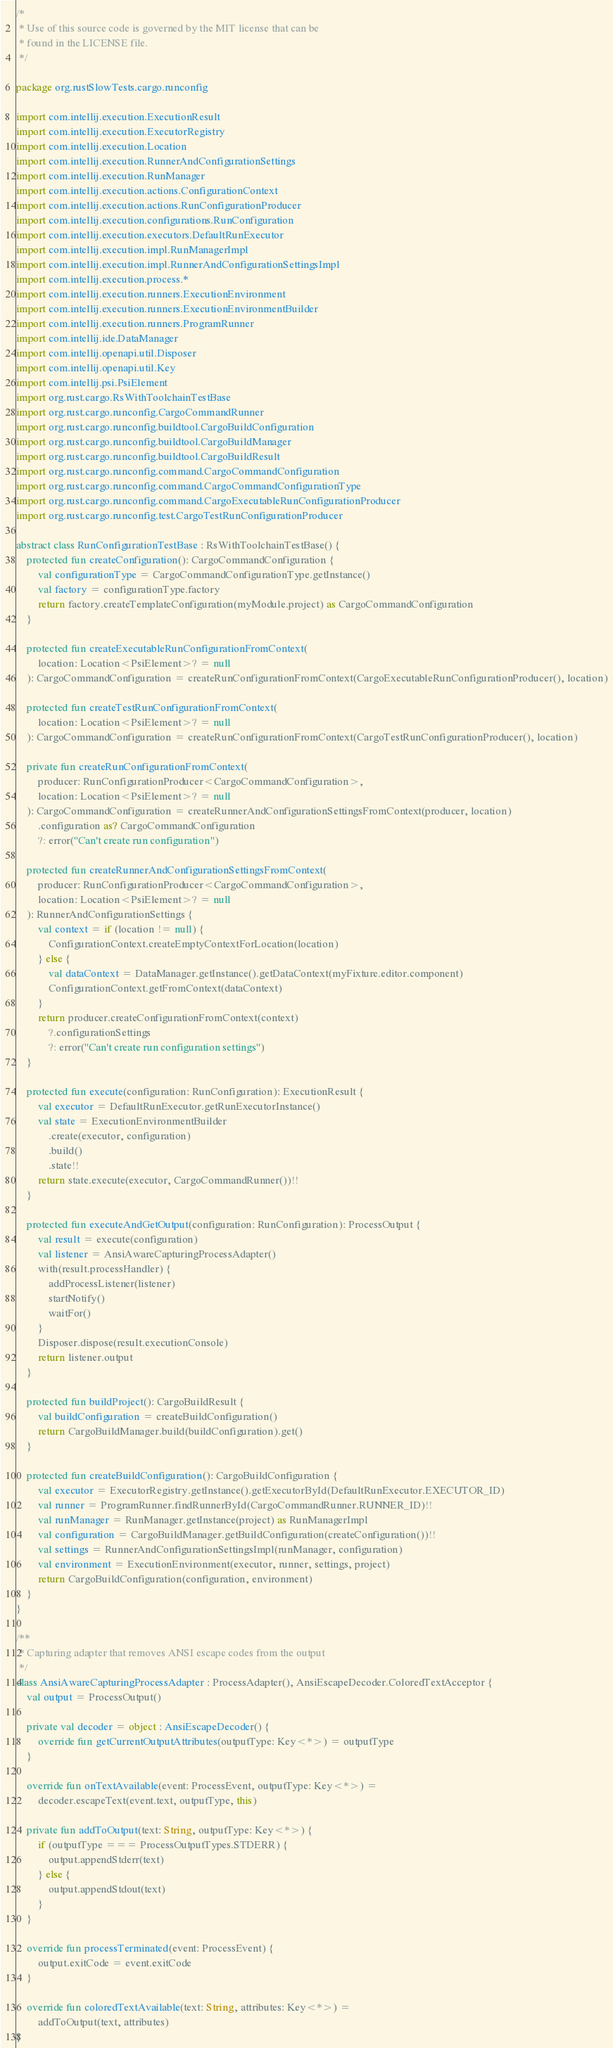Convert code to text. <code><loc_0><loc_0><loc_500><loc_500><_Kotlin_>/*
 * Use of this source code is governed by the MIT license that can be
 * found in the LICENSE file.
 */

package org.rustSlowTests.cargo.runconfig

import com.intellij.execution.ExecutionResult
import com.intellij.execution.ExecutorRegistry
import com.intellij.execution.Location
import com.intellij.execution.RunnerAndConfigurationSettings
import com.intellij.execution.RunManager
import com.intellij.execution.actions.ConfigurationContext
import com.intellij.execution.actions.RunConfigurationProducer
import com.intellij.execution.configurations.RunConfiguration
import com.intellij.execution.executors.DefaultRunExecutor
import com.intellij.execution.impl.RunManagerImpl
import com.intellij.execution.impl.RunnerAndConfigurationSettingsImpl
import com.intellij.execution.process.*
import com.intellij.execution.runners.ExecutionEnvironment
import com.intellij.execution.runners.ExecutionEnvironmentBuilder
import com.intellij.execution.runners.ProgramRunner
import com.intellij.ide.DataManager
import com.intellij.openapi.util.Disposer
import com.intellij.openapi.util.Key
import com.intellij.psi.PsiElement
import org.rust.cargo.RsWithToolchainTestBase
import org.rust.cargo.runconfig.CargoCommandRunner
import org.rust.cargo.runconfig.buildtool.CargoBuildConfiguration
import org.rust.cargo.runconfig.buildtool.CargoBuildManager
import org.rust.cargo.runconfig.buildtool.CargoBuildResult
import org.rust.cargo.runconfig.command.CargoCommandConfiguration
import org.rust.cargo.runconfig.command.CargoCommandConfigurationType
import org.rust.cargo.runconfig.command.CargoExecutableRunConfigurationProducer
import org.rust.cargo.runconfig.test.CargoTestRunConfigurationProducer

abstract class RunConfigurationTestBase : RsWithToolchainTestBase() {
    protected fun createConfiguration(): CargoCommandConfiguration {
        val configurationType = CargoCommandConfigurationType.getInstance()
        val factory = configurationType.factory
        return factory.createTemplateConfiguration(myModule.project) as CargoCommandConfiguration
    }

    protected fun createExecutableRunConfigurationFromContext(
        location: Location<PsiElement>? = null
    ): CargoCommandConfiguration = createRunConfigurationFromContext(CargoExecutableRunConfigurationProducer(), location)

    protected fun createTestRunConfigurationFromContext(
        location: Location<PsiElement>? = null
    ): CargoCommandConfiguration = createRunConfigurationFromContext(CargoTestRunConfigurationProducer(), location)

    private fun createRunConfigurationFromContext(
        producer: RunConfigurationProducer<CargoCommandConfiguration>,
        location: Location<PsiElement>? = null
    ): CargoCommandConfiguration = createRunnerAndConfigurationSettingsFromContext(producer, location)
        .configuration as? CargoCommandConfiguration
        ?: error("Can't create run configuration")

    protected fun createRunnerAndConfigurationSettingsFromContext(
        producer: RunConfigurationProducer<CargoCommandConfiguration>,
        location: Location<PsiElement>? = null
    ): RunnerAndConfigurationSettings {
        val context = if (location != null) {
            ConfigurationContext.createEmptyContextForLocation(location)
        } else {
            val dataContext = DataManager.getInstance().getDataContext(myFixture.editor.component)
            ConfigurationContext.getFromContext(dataContext)
        }
        return producer.createConfigurationFromContext(context)
            ?.configurationSettings
            ?: error("Can't create run configuration settings")
    }

    protected fun execute(configuration: RunConfiguration): ExecutionResult {
        val executor = DefaultRunExecutor.getRunExecutorInstance()
        val state = ExecutionEnvironmentBuilder
            .create(executor, configuration)
            .build()
            .state!!
        return state.execute(executor, CargoCommandRunner())!!
    }

    protected fun executeAndGetOutput(configuration: RunConfiguration): ProcessOutput {
        val result = execute(configuration)
        val listener = AnsiAwareCapturingProcessAdapter()
        with(result.processHandler) {
            addProcessListener(listener)
            startNotify()
            waitFor()
        }
        Disposer.dispose(result.executionConsole)
        return listener.output
    }

    protected fun buildProject(): CargoBuildResult {
        val buildConfiguration = createBuildConfiguration()
        return CargoBuildManager.build(buildConfiguration).get()
    }

    protected fun createBuildConfiguration(): CargoBuildConfiguration {
        val executor = ExecutorRegistry.getInstance().getExecutorById(DefaultRunExecutor.EXECUTOR_ID)
        val runner = ProgramRunner.findRunnerById(CargoCommandRunner.RUNNER_ID)!!
        val runManager = RunManager.getInstance(project) as RunManagerImpl
        val configuration = CargoBuildManager.getBuildConfiguration(createConfiguration())!!
        val settings = RunnerAndConfigurationSettingsImpl(runManager, configuration)
        val environment = ExecutionEnvironment(executor, runner, settings, project)
        return CargoBuildConfiguration(configuration, environment)
    }
}

/**
 * Capturing adapter that removes ANSI escape codes from the output
 */
class AnsiAwareCapturingProcessAdapter : ProcessAdapter(), AnsiEscapeDecoder.ColoredTextAcceptor {
    val output = ProcessOutput()

    private val decoder = object : AnsiEscapeDecoder() {
        override fun getCurrentOutputAttributes(outputType: Key<*>) = outputType
    }

    override fun onTextAvailable(event: ProcessEvent, outputType: Key<*>) =
        decoder.escapeText(event.text, outputType, this)

    private fun addToOutput(text: String, outputType: Key<*>) {
        if (outputType === ProcessOutputTypes.STDERR) {
            output.appendStderr(text)
        } else {
            output.appendStdout(text)
        }
    }

    override fun processTerminated(event: ProcessEvent) {
        output.exitCode = event.exitCode
    }

    override fun coloredTextAvailable(text: String, attributes: Key<*>) =
        addToOutput(text, attributes)
}
</code> 